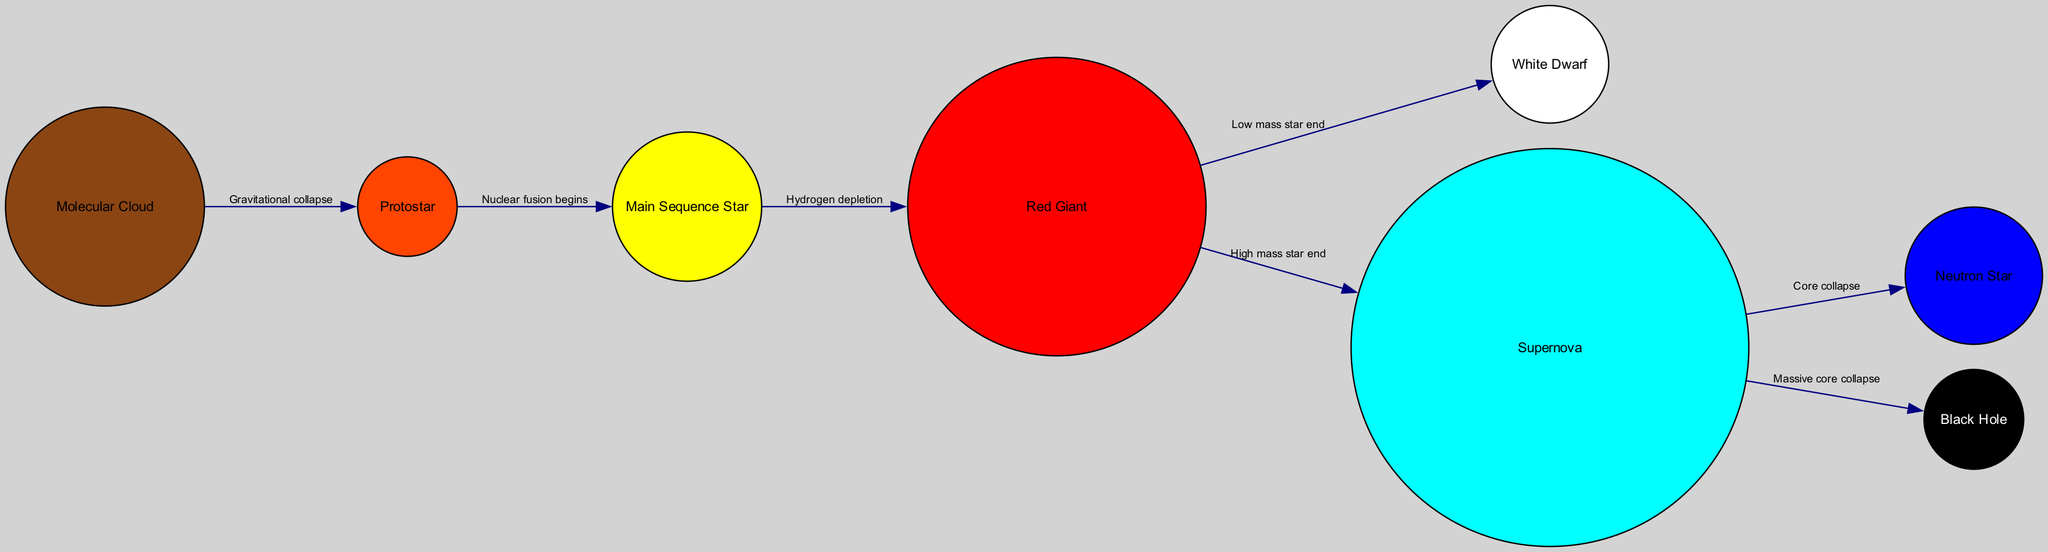What is the first stage of a star's life cycle in the diagram? The diagram starts with the "Molecular Cloud," which is the fundamental building block where stars begin their formation through gravitational collapse.
Answer: Molecular Cloud What color represents the Red Giant stage? The Red Giant stage is represented by the color red (#FF0000) as indicated by the node color coding in the diagram.
Answer: Red How many nodes are there in the star life cycle diagram? The diagram contains a total of eight nodes which represent different stages in the life cycle of a star.
Answer: Eight What process occurs between the Protostar and Main Sequence stages? The diagram indicates that "Nuclear fusion begins" as the critical process that occurs during the transition from a Protostar to a Main Sequence Star.
Answer: Nuclear fusion begins What is the relationship between the Red Giant and White Dwarf? The diagram shows that the Red Giant transforms into a White Dwarf, as indicated by the edge labeled "Low mass star end," suggesting that not all Red Giants become Supernovae.
Answer: Low mass star end What happens to a star after a Supernova if it has a massive core? The diagram illustrates that after a Supernova, a star with a massive core leads to the formation of a Black Hole, highlighting a significant endpoint based on the star's mass.
Answer: Black Hole What is indicated as the final fate for a neutron star? The diagram reports that there is no further fate indicated for a neutron star after its formation from a supernova collapse; it remains stationary in the context of the provided connections.
Answer: None How many edges connect the Protostar to other stages? The Protostar stage is connected by one edge to the Main Sequence stage, indicating a singular but essential relationship in the star formation process.
Answer: One What does the edge labeled "Core collapse" signify? The edge labeled "Core collapse" signifies the transition from a Supernova to a Neutron Star, indicating the fate of the star after exhausting its nuclear energy and undergoing catastrophic collapse.
Answer: Core collapse 